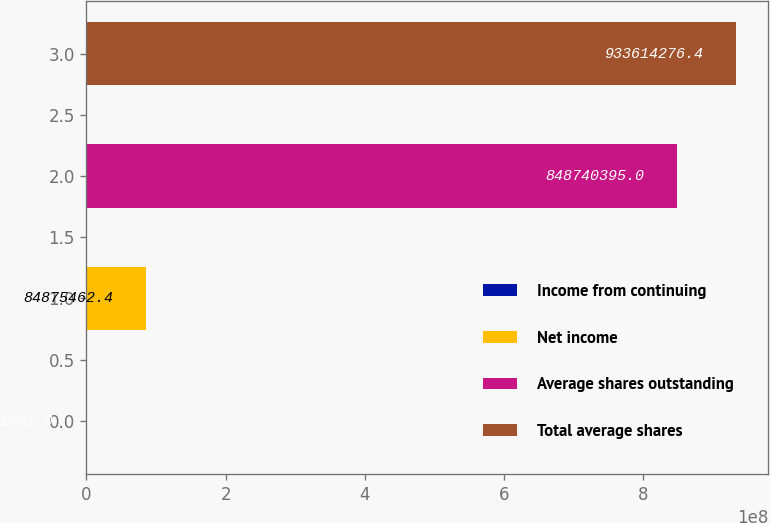Convert chart. <chart><loc_0><loc_0><loc_500><loc_500><bar_chart><fcel>Income from continuing<fcel>Net income<fcel>Average shares outstanding<fcel>Total average shares<nl><fcel>1581<fcel>8.48755e+07<fcel>8.4874e+08<fcel>9.33614e+08<nl></chart> 